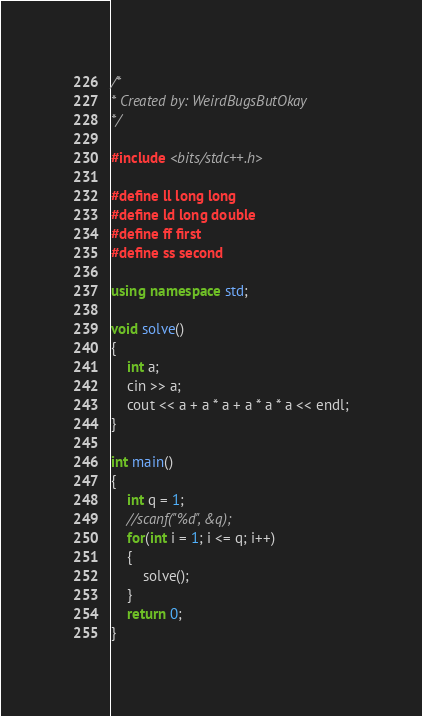Convert code to text. <code><loc_0><loc_0><loc_500><loc_500><_C++_>/*
* Created by: WeirdBugsButOkay
*/

#include <bits/stdc++.h>

#define ll long long
#define ld long double
#define ff first
#define ss second

using namespace std;

void solve()
{
    int a;
    cin >> a;
    cout << a + a * a + a * a * a << endl;
}

int main()
{
    int q = 1;
    //scanf("%d", &q);
    for(int i = 1; i <= q; i++)
    {
        solve();
    }
    return 0;
}</code> 